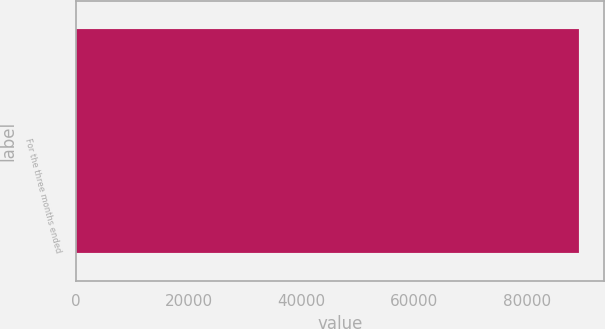<chart> <loc_0><loc_0><loc_500><loc_500><bar_chart><fcel>For the three months ended<nl><fcel>89218<nl></chart> 